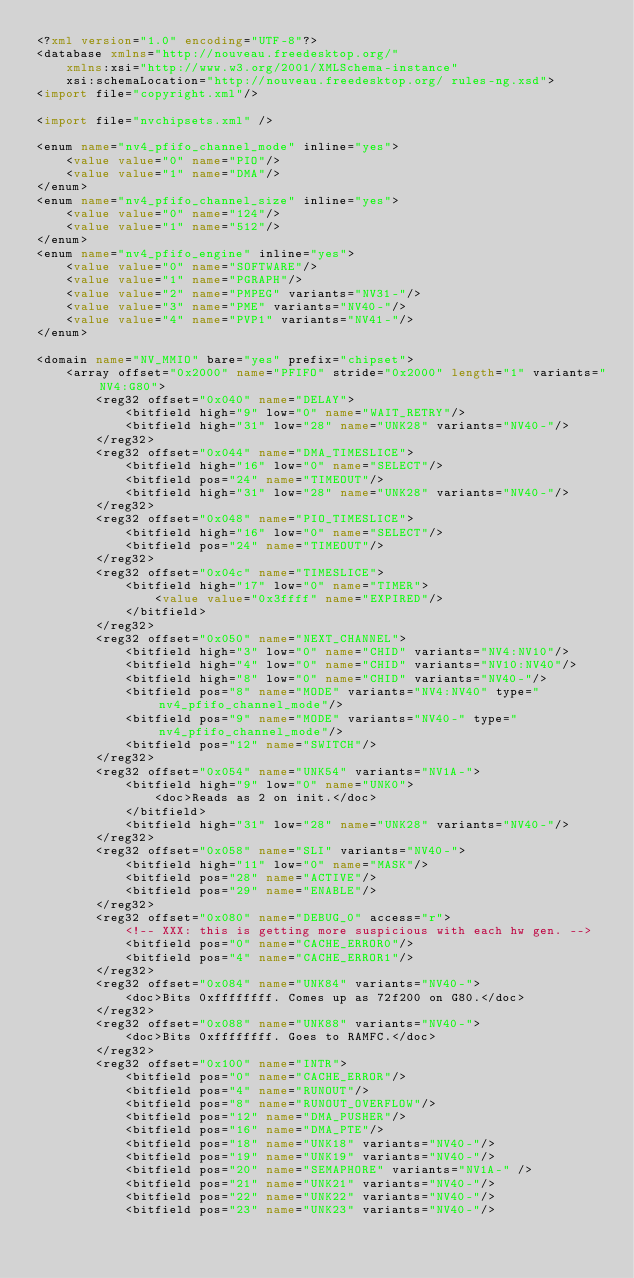<code> <loc_0><loc_0><loc_500><loc_500><_XML_><?xml version="1.0" encoding="UTF-8"?>
<database xmlns="http://nouveau.freedesktop.org/"
	xmlns:xsi="http://www.w3.org/2001/XMLSchema-instance"
	xsi:schemaLocation="http://nouveau.freedesktop.org/ rules-ng.xsd">
<import file="copyright.xml"/>

<import file="nvchipsets.xml" />

<enum name="nv4_pfifo_channel_mode" inline="yes">
	<value value="0" name="PIO"/>
	<value value="1" name="DMA"/>
</enum>
<enum name="nv4_pfifo_channel_size" inline="yes">
	<value value="0" name="124"/>
	<value value="1" name="512"/>
</enum>
<enum name="nv4_pfifo_engine" inline="yes">
	<value value="0" name="SOFTWARE"/>
	<value value="1" name="PGRAPH"/>
	<value value="2" name="PMPEG" variants="NV31-"/>
	<value value="3" name="PME" variants="NV40-"/>
	<value value="4" name="PVP1" variants="NV41-"/>
</enum>

<domain name="NV_MMIO" bare="yes" prefix="chipset">
	<array offset="0x2000" name="PFIFO" stride="0x2000" length="1" variants="NV4:G80">
		<reg32 offset="0x040" name="DELAY">
			<bitfield high="9" low="0" name="WAIT_RETRY"/>
			<bitfield high="31" low="28" name="UNK28" variants="NV40-"/>
		</reg32>
		<reg32 offset="0x044" name="DMA_TIMESLICE">
			<bitfield high="16" low="0" name="SELECT"/>
			<bitfield pos="24" name="TIMEOUT"/>
			<bitfield high="31" low="28" name="UNK28" variants="NV40-"/>
		</reg32>
		<reg32 offset="0x048" name="PIO_TIMESLICE">
			<bitfield high="16" low="0" name="SELECT"/>
			<bitfield pos="24" name="TIMEOUT"/>
		</reg32>
		<reg32 offset="0x04c" name="TIMESLICE">
			<bitfield high="17" low="0" name="TIMER">
				<value value="0x3ffff" name="EXPIRED"/>
			</bitfield>
		</reg32>
		<reg32 offset="0x050" name="NEXT_CHANNEL">
			<bitfield high="3" low="0" name="CHID" variants="NV4:NV10"/>
			<bitfield high="4" low="0" name="CHID" variants="NV10:NV40"/>
			<bitfield high="8" low="0" name="CHID" variants="NV40-"/>
			<bitfield pos="8" name="MODE" variants="NV4:NV40" type="nv4_pfifo_channel_mode"/>
			<bitfield pos="9" name="MODE" variants="NV40-" type="nv4_pfifo_channel_mode"/>
			<bitfield pos="12" name="SWITCH"/>
		</reg32>
		<reg32 offset="0x054" name="UNK54" variants="NV1A-">
			<bitfield high="9" low="0" name="UNK0">
				<doc>Reads as 2 on init.</doc>
			</bitfield>
			<bitfield high="31" low="28" name="UNK28" variants="NV40-"/>
		</reg32>
		<reg32 offset="0x058" name="SLI" variants="NV40-">
			<bitfield high="11" low="0" name="MASK"/>
			<bitfield pos="28" name="ACTIVE"/>
			<bitfield pos="29" name="ENABLE"/>
		</reg32>
		<reg32 offset="0x080" name="DEBUG_0" access="r">
			<!-- XXX: this is getting more suspicious with each hw gen. -->
			<bitfield pos="0" name="CACHE_ERROR0"/>
			<bitfield pos="4" name="CACHE_ERROR1"/>
		</reg32>
		<reg32 offset="0x084" name="UNK84" variants="NV40-">
			<doc>Bits 0xffffffff. Comes up as 72f200 on G80.</doc>
		</reg32>
		<reg32 offset="0x088" name="UNK88" variants="NV40-">
			<doc>Bits 0xffffffff. Goes to RAMFC.</doc>
		</reg32>
		<reg32 offset="0x100" name="INTR">
			<bitfield pos="0" name="CACHE_ERROR"/>
			<bitfield pos="4" name="RUNOUT"/>
			<bitfield pos="8" name="RUNOUT_OVERFLOW"/>
			<bitfield pos="12" name="DMA_PUSHER"/>
			<bitfield pos="16" name="DMA_PTE"/>
			<bitfield pos="18" name="UNK18" variants="NV40-"/>
			<bitfield pos="19" name="UNK19" variants="NV40-"/>
			<bitfield pos="20" name="SEMAPHORE" variants="NV1A-" />
			<bitfield pos="21" name="UNK21" variants="NV40-"/>
			<bitfield pos="22" name="UNK22" variants="NV40-"/>
			<bitfield pos="23" name="UNK23" variants="NV40-"/></code> 